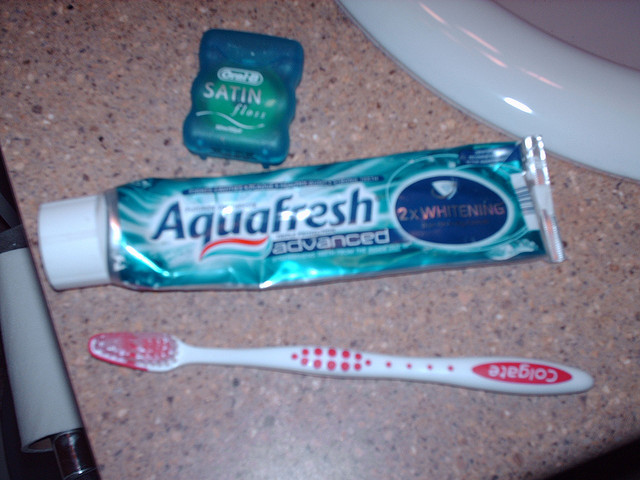Read and extract the text from this image. AquaFresh advanced Colgate satin Oral-B 2XWHITENING 